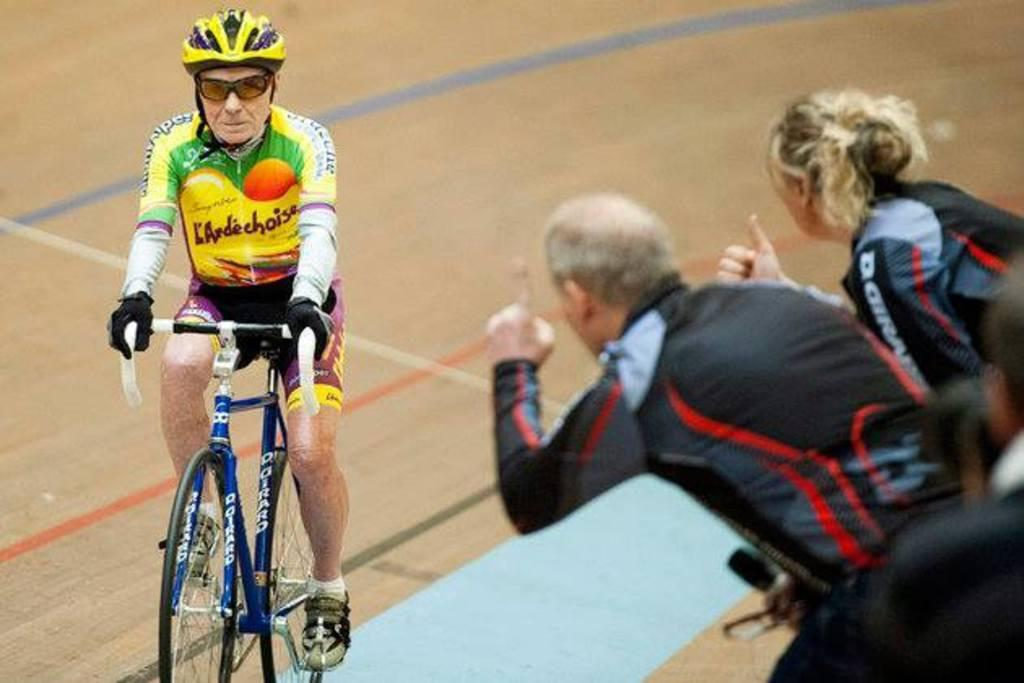How many people are in the image? There are three people in the image. Can you describe the attire of one of the individuals? There is a man wearing a helmet, goggles, gloves, and shoes. What activity is the man engaged in? The man is riding a bicycle. What is the position of the bicycle in the image? The bicycle is on the ground. What type of boundary can be seen in the image? There is no boundary visible in the image. Can you tell me where the church is located in the image? There is no church present in the image. 